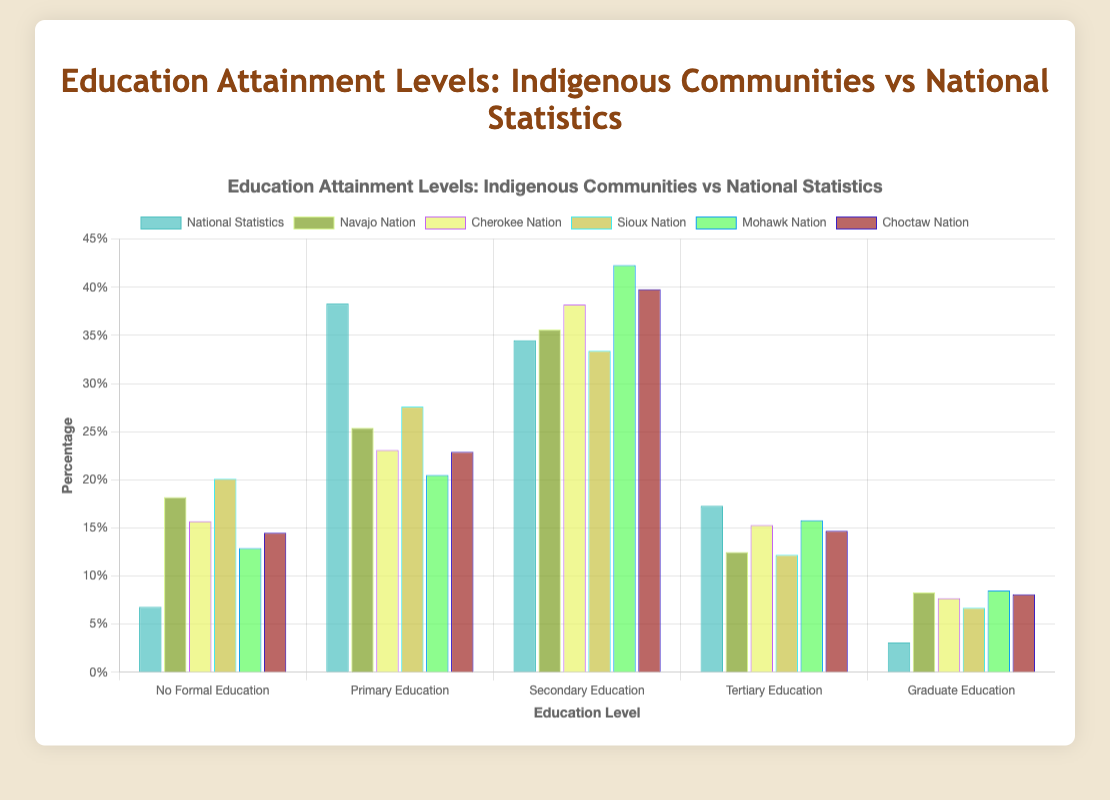What proportion of the Navajo Nation has no formal education compared to the national statistics? To determine the proportion, refer to the grouped bars for the "No Formal Education" category. The bar for the Navajo Nation shows 18.2%, while the national statistics bar shows 6.8%.
Answer: The Navajo Nation has a higher proportion of no formal education compared to the national statistics In which category do indigenous communities overall have higher educational attainment levels than the national statistics? Compare the heights of bars for all categories. Notice that in the "Graduate Education" category, all indigenous communities show a percentage higher than the national statistics bar (3.1%).
Answer: Graduate Education Which indigenous community has the highest percentage of secondary education attainment? Compare the heights of the bars for each community in the "Secondary Education" category. The Mohawk Nation has the highest percentage at 42.3%.
Answer: Mohawk Nation How does the percentage of tertiary education attainment in the Choctaw Nation compare to the national statistics? Refer to the "Tertiary Education" bar heights for the Choctaw Nation and the national statistics. The Choctaw Nation has 14.7%, whereas the national statistics show 17.3%.
Answer: The Choctaw Nation has a lower percentage of tertiary education attainment compared to the national statistics Calculate the average percentage of primary education attainment across all indigenous communities. Add the percentages of primary education for each community (25.4 + 23.1 + 27.6 + 20.5 + 22.9) and divide by the number of communities (5). The sum is 119.5, and the average is 119.5/5.
Answer: 23.9% Which education level shows the greatest disparity between an indigenous community and national statistics? Find the education level with the largest difference between the highest indigenous community value and the national statistics. "No Formal Education" has the highest disparity of 20.1% (Sioux Nation) compared to 6.8%.
Answer: No Formal Education For the Navajo Nation, how does the proportion with graduate education compare to the national statistics? Refer to the "Graduate Education" category bar heights for the Navajo Nation and national statistics. The Navajo Nation shows 8.3%, while national statistics show 3.1%. Calculate the difference.
Answer: The Navajo Nation has 5.2% more Across all categories, which indigenous community appears most frequently as having a higher percentage than the national statistics? Count the instances where each community’s bar height is greater than the national statistics’ bar across all categories. The Choctaw Nation appears the most frequently.
Answer: Choctaw Nation Summarize the educational attainment trend for the indigenous communities compared to national statistics. Generally, indigenous communities show higher percentages in no formal education and graduate education compared to national statistics but lower percentages in primary and tertiary education. Secondary education attainment is similar.
Answer: Indigenous communities have higher no formal and graduate education, lower primary and tertiary education, and similar secondary education 